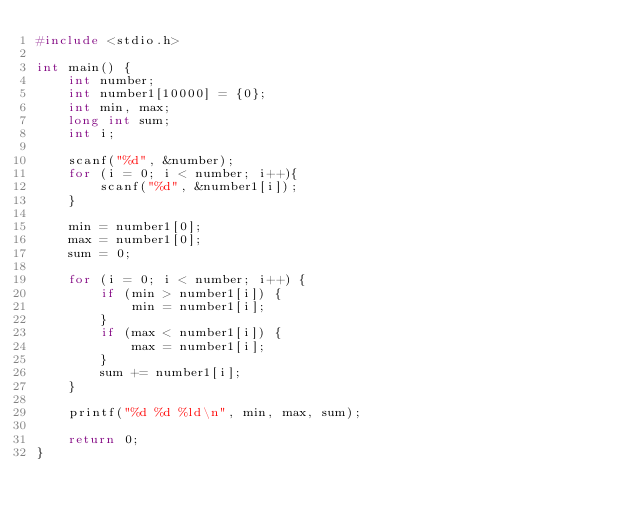Convert code to text. <code><loc_0><loc_0><loc_500><loc_500><_C_>#include <stdio.h>

int main() {
    int number; 
    int number1[10000] = {0};
    int min, max; 
    long int sum;
    int i;

    scanf("%d", &number);
    for (i = 0; i < number; i++){
        scanf("%d", &number1[i]);
    }
    
    min = number1[0];
    max = number1[0];
    sum = 0;

    for (i = 0; i < number; i++) {
        if (min > number1[i]) {
            min = number1[i];
        }
        if (max < number1[i]) {
            max = number1[i];
        }
        sum += number1[i];
    }

    printf("%d %d %ld\n", min, max, sum);

    return 0;
}</code> 